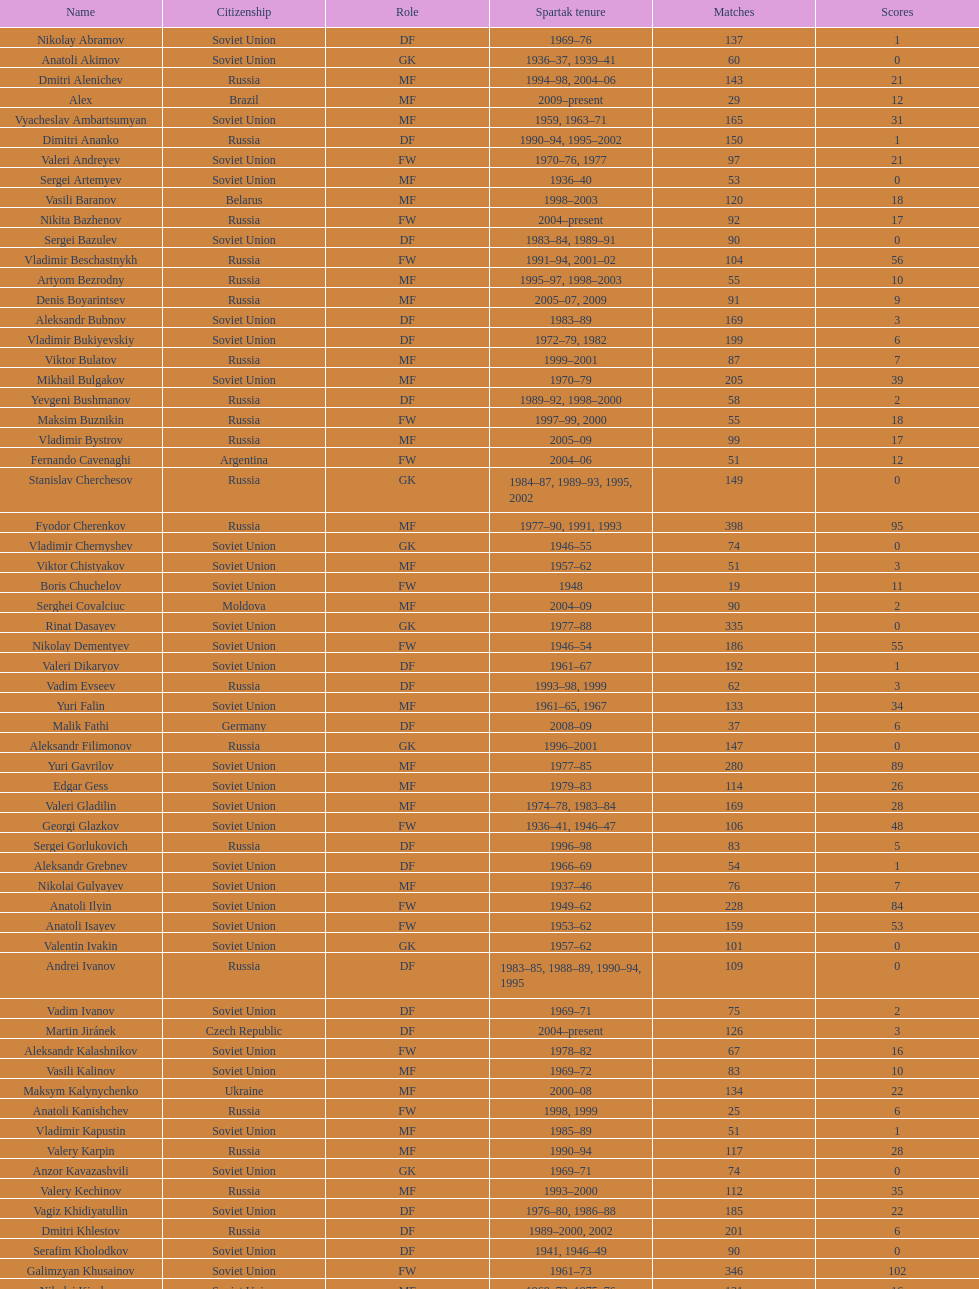Which player has the most appearances with the club? Fyodor Cherenkov. Can you parse all the data within this table? {'header': ['Name', 'Citizenship', 'Role', 'Spartak tenure', 'Matches', 'Scores'], 'rows': [['Nikolay Abramov', 'Soviet Union', 'DF', '1969–76', '137', '1'], ['Anatoli Akimov', 'Soviet Union', 'GK', '1936–37, 1939–41', '60', '0'], ['Dmitri Alenichev', 'Russia', 'MF', '1994–98, 2004–06', '143', '21'], ['Alex', 'Brazil', 'MF', '2009–present', '29', '12'], ['Vyacheslav Ambartsumyan', 'Soviet Union', 'MF', '1959, 1963–71', '165', '31'], ['Dimitri Ananko', 'Russia', 'DF', '1990–94, 1995–2002', '150', '1'], ['Valeri Andreyev', 'Soviet Union', 'FW', '1970–76, 1977', '97', '21'], ['Sergei Artemyev', 'Soviet Union', 'MF', '1936–40', '53', '0'], ['Vasili Baranov', 'Belarus', 'MF', '1998–2003', '120', '18'], ['Nikita Bazhenov', 'Russia', 'FW', '2004–present', '92', '17'], ['Sergei Bazulev', 'Soviet Union', 'DF', '1983–84, 1989–91', '90', '0'], ['Vladimir Beschastnykh', 'Russia', 'FW', '1991–94, 2001–02', '104', '56'], ['Artyom Bezrodny', 'Russia', 'MF', '1995–97, 1998–2003', '55', '10'], ['Denis Boyarintsev', 'Russia', 'MF', '2005–07, 2009', '91', '9'], ['Aleksandr Bubnov', 'Soviet Union', 'DF', '1983–89', '169', '3'], ['Vladimir Bukiyevskiy', 'Soviet Union', 'DF', '1972–79, 1982', '199', '6'], ['Viktor Bulatov', 'Russia', 'MF', '1999–2001', '87', '7'], ['Mikhail Bulgakov', 'Soviet Union', 'MF', '1970–79', '205', '39'], ['Yevgeni Bushmanov', 'Russia', 'DF', '1989–92, 1998–2000', '58', '2'], ['Maksim Buznikin', 'Russia', 'FW', '1997–99, 2000', '55', '18'], ['Vladimir Bystrov', 'Russia', 'MF', '2005–09', '99', '17'], ['Fernando Cavenaghi', 'Argentina', 'FW', '2004–06', '51', '12'], ['Stanislav Cherchesov', 'Russia', 'GK', '1984–87, 1989–93, 1995, 2002', '149', '0'], ['Fyodor Cherenkov', 'Russia', 'MF', '1977–90, 1991, 1993', '398', '95'], ['Vladimir Chernyshev', 'Soviet Union', 'GK', '1946–55', '74', '0'], ['Viktor Chistyakov', 'Soviet Union', 'MF', '1957–62', '51', '3'], ['Boris Chuchelov', 'Soviet Union', 'FW', '1948', '19', '11'], ['Serghei Covalciuc', 'Moldova', 'MF', '2004–09', '90', '2'], ['Rinat Dasayev', 'Soviet Union', 'GK', '1977–88', '335', '0'], ['Nikolay Dementyev', 'Soviet Union', 'FW', '1946–54', '186', '55'], ['Valeri Dikaryov', 'Soviet Union', 'DF', '1961–67', '192', '1'], ['Vadim Evseev', 'Russia', 'DF', '1993–98, 1999', '62', '3'], ['Yuri Falin', 'Soviet Union', 'MF', '1961–65, 1967', '133', '34'], ['Malik Fathi', 'Germany', 'DF', '2008–09', '37', '6'], ['Aleksandr Filimonov', 'Russia', 'GK', '1996–2001', '147', '0'], ['Yuri Gavrilov', 'Soviet Union', 'MF', '1977–85', '280', '89'], ['Edgar Gess', 'Soviet Union', 'MF', '1979–83', '114', '26'], ['Valeri Gladilin', 'Soviet Union', 'MF', '1974–78, 1983–84', '169', '28'], ['Georgi Glazkov', 'Soviet Union', 'FW', '1936–41, 1946–47', '106', '48'], ['Sergei Gorlukovich', 'Russia', 'DF', '1996–98', '83', '5'], ['Aleksandr Grebnev', 'Soviet Union', 'DF', '1966–69', '54', '1'], ['Nikolai Gulyayev', 'Soviet Union', 'MF', '1937–46', '76', '7'], ['Anatoli Ilyin', 'Soviet Union', 'FW', '1949–62', '228', '84'], ['Anatoli Isayev', 'Soviet Union', 'FW', '1953–62', '159', '53'], ['Valentin Ivakin', 'Soviet Union', 'GK', '1957–62', '101', '0'], ['Andrei Ivanov', 'Russia', 'DF', '1983–85, 1988–89, 1990–94, 1995', '109', '0'], ['Vadim Ivanov', 'Soviet Union', 'DF', '1969–71', '75', '2'], ['Martin Jiránek', 'Czech Republic', 'DF', '2004–present', '126', '3'], ['Aleksandr Kalashnikov', 'Soviet Union', 'FW', '1978–82', '67', '16'], ['Vasili Kalinov', 'Soviet Union', 'MF', '1969–72', '83', '10'], ['Maksym Kalynychenko', 'Ukraine', 'MF', '2000–08', '134', '22'], ['Anatoli Kanishchev', 'Russia', 'FW', '1998, 1999', '25', '6'], ['Vladimir Kapustin', 'Soviet Union', 'MF', '1985–89', '51', '1'], ['Valery Karpin', 'Russia', 'MF', '1990–94', '117', '28'], ['Anzor Kavazashvili', 'Soviet Union', 'GK', '1969–71', '74', '0'], ['Valery Kechinov', 'Russia', 'MF', '1993–2000', '112', '35'], ['Vagiz Khidiyatullin', 'Soviet Union', 'DF', '1976–80, 1986–88', '185', '22'], ['Dmitri Khlestov', 'Russia', 'DF', '1989–2000, 2002', '201', '6'], ['Serafim Kholodkov', 'Soviet Union', 'DF', '1941, 1946–49', '90', '0'], ['Galimzyan Khusainov', 'Soviet Union', 'FW', '1961–73', '346', '102'], ['Nikolai Kiselyov', 'Soviet Union', 'MF', '1968–73, 1975–76', '131', '16'], ['Aleksandr Kokorev', 'Soviet Union', 'MF', '1972–80', '90', '4'], ['Ivan Konov', 'Soviet Union', 'FW', '1945–48', '85', '31'], ['Viktor Konovalov', 'Soviet Union', 'MF', '1960–61', '24', '5'], ['Alexey Korneyev', 'Soviet Union', 'DF', '1957–67', '177', '0'], ['Pavel Kornilov', 'Soviet Union', 'FW', '1938–41', '65', '38'], ['Radoslav Kováč', 'Czech Republic', 'MF', '2005–08', '101', '9'], ['Yuri Kovtun', 'Russia', 'DF', '1999–2005', '122', '7'], ['Wojciech Kowalewski', 'Poland', 'GK', '2003–07', '94', '0'], ['Anatoly Krutikov', 'Soviet Union', 'DF', '1959–69', '269', '9'], ['Dmitri Kudryashov', 'Russia', 'MF', '2002', '22', '5'], ['Vasili Kulkov', 'Russia', 'DF', '1986, 1989–91, 1995, 1997', '93', '4'], ['Boris Kuznetsov', 'Soviet Union', 'DF', '1985–88, 1989–90', '90', '0'], ['Yevgeni Kuznetsov', 'Soviet Union', 'MF', '1982–89', '209', '23'], ['Igor Lediakhov', 'Russia', 'MF', '1992–94', '65', '21'], ['Aleksei Leontyev', 'Soviet Union', 'GK', '1940–49', '109', '0'], ['Boris Lobutev', 'Soviet Union', 'FW', '1957–60', '15', '7'], ['Gennady Logofet', 'Soviet Union', 'DF', '1960–75', '349', '27'], ['Evgeny Lovchev', 'Soviet Union', 'MF', '1969–78', '249', '30'], ['Konstantin Malinin', 'Soviet Union', 'DF', '1939–50', '140', '7'], ['Ramiz Mamedov', 'Russia', 'DF', '1991–98', '125', '6'], ['Valeri Masalitin', 'Russia', 'FW', '1994–95', '7', '5'], ['Vladimir Maslachenko', 'Soviet Union', 'GK', '1962–68', '196', '0'], ['Anatoli Maslyonkin', 'Soviet Union', 'DF', '1954–63', '216', '8'], ['Aleksei Melyoshin', 'Russia', 'MF', '1995–2000', '68', '5'], ['Aleksandr Minayev', 'Soviet Union', 'MF', '1972–75', '92', '10'], ['Alexander Mirzoyan', 'Soviet Union', 'DF', '1979–83', '80', '9'], ['Vitali Mirzoyev', 'Soviet Union', 'FW', '1971–74', '58', '4'], ['Viktor Mishin', 'Soviet Union', 'FW', '1956–61', '43', '8'], ['Igor Mitreski', 'Macedonia', 'DF', '2001–04', '85', '0'], ['Gennady Morozov', 'Soviet Union', 'DF', '1980–86, 1989–90', '196', '3'], ['Aleksandr Mostovoi', 'Soviet Union', 'MF', '1986–91', '106', '34'], ['Mozart', 'Brazil', 'MF', '2005–08', '68', '7'], ['Ivan Mozer', 'Soviet Union', 'MF', '1956–61', '96', '30'], ['Mukhsin Mukhamadiev', 'Russia', 'MF', '1994–95', '30', '13'], ['Igor Netto', 'Soviet Union', 'MF', '1949–66', '368', '36'], ['Yuriy Nikiforov', 'Russia', 'DF', '1993–96', '85', '16'], ['Vladimir Nikonov', 'Soviet Union', 'MF', '1979–80, 1982', '25', '5'], ['Sergei Novikov', 'Soviet Union', 'MF', '1978–80, 1985–89', '70', '12'], ['Mikhail Ogonkov', 'Soviet Union', 'DF', '1953–58, 1961', '78', '0'], ['Sergei Olshansky', 'Soviet Union', 'DF', '1969–75', '138', '7'], ['Viktor Onopko', 'Russia', 'DF', '1992–95', '108', '23'], ['Nikolai Osyanin', 'Soviet Union', 'DF', '1966–71, 1974–76', '248', '50'], ['Viktor Papayev', 'Soviet Union', 'MF', '1968–73, 1975–76', '174', '10'], ['Aleksei Paramonov', 'Soviet Union', 'MF', '1947–59', '264', '61'], ['Dmytro Parfenov', 'Ukraine', 'DF', '1998–2005', '125', '15'], ['Nikolai Parshin', 'Soviet Union', 'FW', '1949–58', '106', '36'], ['Viktor Pasulko', 'Soviet Union', 'MF', '1987–89', '75', '16'], ['Aleksandr Pavlenko', 'Russia', 'MF', '2001–07, 2008–09', '110', '11'], ['Vadim Pavlenko', 'Soviet Union', 'FW', '1977–78', '47', '16'], ['Roman Pavlyuchenko', 'Russia', 'FW', '2003–08', '141', '69'], ['Hennadiy Perepadenko', 'Ukraine', 'MF', '1990–91, 1992', '51', '6'], ['Boris Petrov', 'Soviet Union', 'FW', '1962', '18', '5'], ['Vladimir Petrov', 'Soviet Union', 'DF', '1959–71', '174', '5'], ['Andrei Piatnitski', 'Russia', 'MF', '1992–97', '100', '17'], ['Nikolai Pisarev', 'Russia', 'FW', '1992–95, 1998, 2000–01', '115', '32'], ['Aleksandr Piskaryov', 'Soviet Union', 'FW', '1971–75', '117', '33'], ['Mihajlo Pjanović', 'Serbia', 'FW', '2003–06', '48', '11'], ['Stipe Pletikosa', 'Croatia', 'GK', '2007–present', '63', '0'], ['Dmitri Popov', 'Russia', 'DF', '1989–93', '78', '7'], ['Boris Pozdnyakov', 'Soviet Union', 'DF', '1978–84, 1989–91', '145', '3'], ['Vladimir Pribylov', 'Soviet Union', 'FW', '1964–69', '35', '6'], ['Aleksandr Prokhorov', 'Soviet Union', 'GK', '1972–75, 1976–78', '143', '0'], ['Andrei Protasov', 'Soviet Union', 'FW', '1939–41', '32', '10'], ['Dmitri Radchenko', 'Russia', 'FW', '1991–93', '61', '27'], ['Vladimir Redin', 'Soviet Union', 'MF', '1970–74, 1976', '90', '12'], ['Valeri Reyngold', 'Soviet Union', 'FW', '1960–67', '176', '32'], ['Luis Robson', 'Brazil', 'FW', '1997–2001', '102', '32'], ['Sergey Rodionov', 'Russia', 'FW', '1979–90, 1993–95', '303', '124'], ['Clemente Rodríguez', 'Argentina', 'DF', '2004–06, 2008–09', '71', '3'], ['Oleg Romantsev', 'Soviet Union', 'DF', '1976–83', '180', '6'], ['Miroslav Romaschenko', 'Belarus', 'MF', '1997–98', '42', '7'], ['Sergei Rozhkov', 'Soviet Union', 'MF', '1961–65, 1967–69, 1974', '143', '8'], ['Andrei Rudakov', 'Soviet Union', 'FW', '1985–87', '49', '17'], ['Leonid Rumyantsev', 'Soviet Union', 'FW', '1936–40', '26', '8'], ['Mikhail Rusyayev', 'Russia', 'FW', '1981–87, 1992', '47', '9'], ['Konstantin Ryazantsev', 'Soviet Union', 'MF', '1941, 1944–51', '114', '5'], ['Aleksandr Rystsov', 'Soviet Union', 'FW', '1947–54', '100', '16'], ['Sergei Salnikov', 'Soviet Union', 'FW', '1946–49, 1955–60', '201', '64'], ['Aleksandr Samedov', 'Russia', 'MF', '2001–05', '47', '6'], ['Viktor Samokhin', 'Soviet Union', 'MF', '1974–81', '188', '3'], ['Yuri Sedov', 'Soviet Union', 'DF', '1948–55, 1957–59', '176', '2'], ['Anatoli Seglin', 'Soviet Union', 'DF', '1945–52', '83', '0'], ['Viktor Semyonov', 'Soviet Union', 'FW', '1937–47', '104', '49'], ['Yuri Sevidov', 'Soviet Union', 'FW', '1960–65', '146', '54'], ['Igor Shalimov', 'Russia', 'MF', '1986–91', '95', '20'], ['Sergey Shavlo', 'Soviet Union', 'MF', '1977–82, 1984–85', '256', '48'], ['Aleksandr Shirko', 'Russia', 'FW', '1993–2001', '128', '40'], ['Roman Shishkin', 'Russia', 'DF', '2003–08', '54', '1'], ['Valeri Shmarov', 'Russia', 'FW', '1987–91, 1995–96', '143', '54'], ['Sergei Shvetsov', 'Soviet Union', 'DF', '1981–84', '68', '14'], ['Yevgeni Sidorov', 'Soviet Union', 'MF', '1974–81, 1984–85', '191', '18'], ['Dzhemal Silagadze', 'Soviet Union', 'FW', '1968–71, 1973', '91', '12'], ['Nikita Simonyan', 'Soviet Union', 'FW', '1949–59', '215', '135'], ['Boris Smyslov', 'Soviet Union', 'FW', '1945–48', '45', '6'], ['Florin Şoavă', 'Romania', 'DF', '2004–05, 2007–08', '52', '1'], ['Vladimir Sochnov', 'Soviet Union', 'DF', '1981–85, 1989', '148', '9'], ['Aleksei Sokolov', 'Soviet Union', 'FW', '1938–41, 1942, 1944–47', '114', '49'], ['Vasili Sokolov', 'Soviet Union', 'DF', '1938–41, 1942–51', '262', '2'], ['Viktor Sokolov', 'Soviet Union', 'DF', '1936–41, 1942–46', '121', '0'], ['Anatoli Soldatov', 'Soviet Union', 'DF', '1958–65', '113', '1'], ['Aleksandr Sorokin', 'Soviet Union', 'MF', '1977–80', '107', '9'], ['Andrei Starostin', 'Soviet Union', 'MF', '1936–40', '95', '4'], ['Vladimir Stepanov', 'Soviet Union', 'FW', '1936–41, 1942', '101', '33'], ['Andrejs Štolcers', 'Latvia', 'MF', '2000', '11', '5'], ['Martin Stranzl', 'Austria', 'DF', '2006–present', '80', '3'], ['Yuri Susloparov', 'Soviet Union', 'DF', '1986–90', '80', '1'], ['Yuri Syomin', 'Soviet Union', 'MF', '1965–67', '43', '6'], ['Dmitri Sychev', 'Russia', 'FW', '2002', '18', '9'], ['Boris Tatushin', 'Soviet Union', 'FW', '1953–58, 1961', '116', '38'], ['Viktor Terentyev', 'Soviet Union', 'FW', '1948–53', '103', '34'], ['Andrey Tikhonov', 'Russia', 'MF', '1992–2000', '191', '68'], ['Oleg Timakov', 'Soviet Union', 'MF', '1945–54', '182', '19'], ['Nikolai Tishchenko', 'Soviet Union', 'DF', '1951–58', '106', '0'], ['Yegor Titov', 'Russia', 'MF', '1992–2008', '324', '86'], ['Eduard Tsykhmeystruk', 'Ukraine', 'FW', '2001–02', '35', '5'], ['Ilya Tsymbalar', 'Russia', 'MF', '1993–99', '146', '42'], ['Grigori Tuchkov', 'Soviet Union', 'DF', '1937–41, 1942, 1944', '74', '2'], ['Vladas Tučkus', 'Soviet Union', 'GK', '1954–57', '60', '0'], ['Ivan Varlamov', 'Soviet Union', 'DF', '1964–68', '75', '0'], ['Welliton', 'Brazil', 'FW', '2007–present', '77', '51'], ['Vladimir Yanishevskiy', 'Soviet Union', 'FW', '1965–66', '46', '7'], ['Vladimir Yankin', 'Soviet Union', 'MF', '1966–70', '93', '19'], ['Georgi Yartsev', 'Soviet Union', 'FW', '1977–80', '116', '55'], ['Valentin Yemyshev', 'Soviet Union', 'FW', '1948–53', '23', '9'], ['Aleksei Yeryomenko', 'Soviet Union', 'MF', '1986–87', '26', '5'], ['Viktor Yevlentyev', 'Soviet Union', 'MF', '1963–65, 1967–70', '56', '11'], ['Sergei Yuran', 'Russia', 'FW', '1995, 1999', '26', '5'], ['Valeri Zenkov', 'Soviet Union', 'DF', '1971–74', '59', '1']]} 